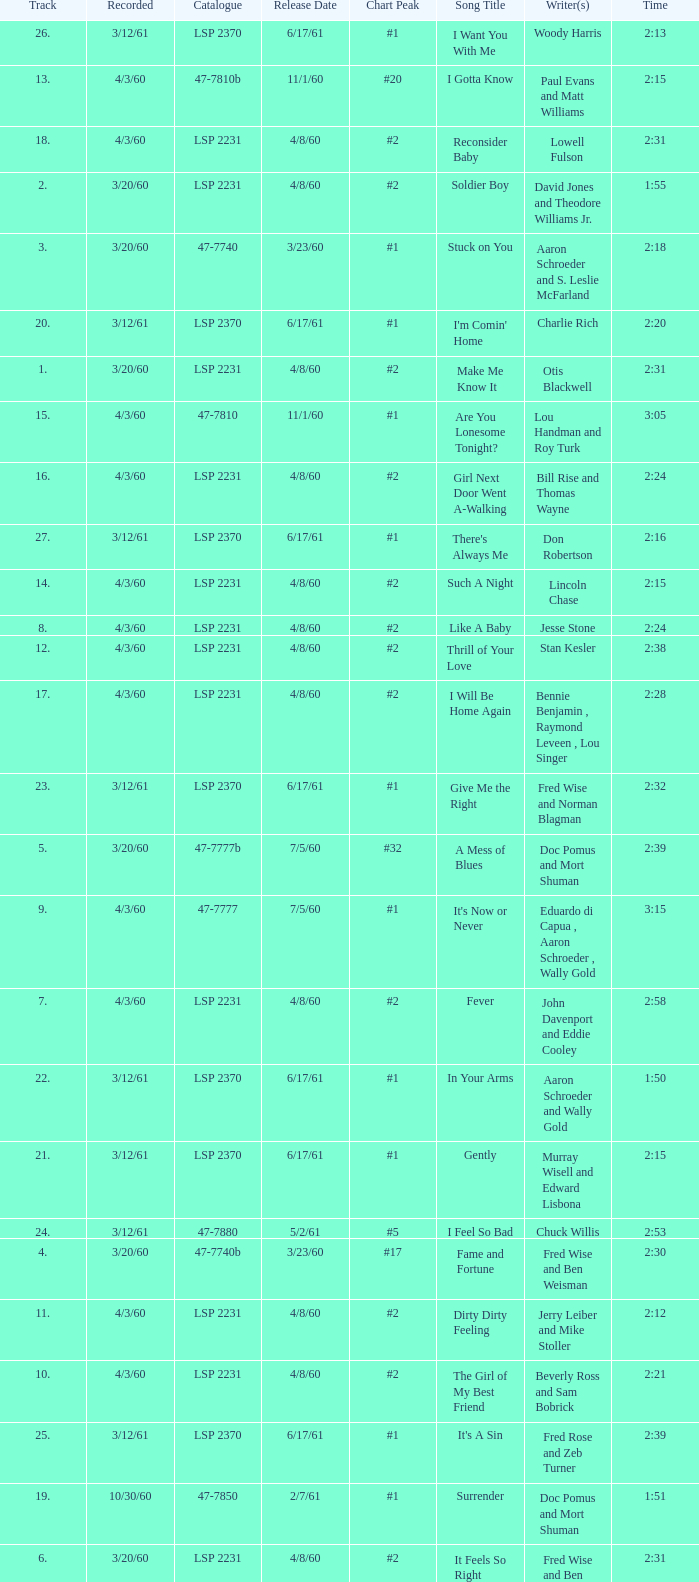On songs with track numbers smaller than number 17 and catalogues of LSP 2231, who are the writer(s)? Otis Blackwell, David Jones and Theodore Williams Jr., Fred Wise and Ben Weisman, John Davenport and Eddie Cooley, Jesse Stone, Beverly Ross and Sam Bobrick, Jerry Leiber and Mike Stoller, Stan Kesler, Lincoln Chase, Bill Rise and Thomas Wayne. 